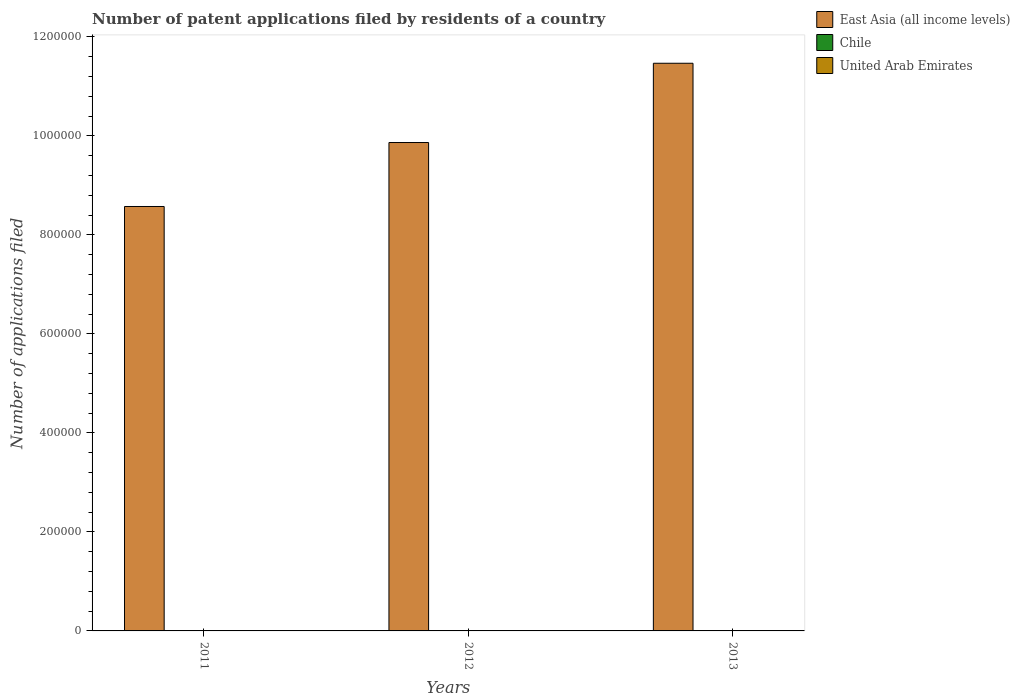How many groups of bars are there?
Give a very brief answer. 3. Are the number of bars on each tick of the X-axis equal?
Give a very brief answer. Yes. How many bars are there on the 2nd tick from the left?
Offer a terse response. 3. How many bars are there on the 1st tick from the right?
Make the answer very short. 3. In how many cases, is the number of bars for a given year not equal to the number of legend labels?
Offer a very short reply. 0. What is the number of applications filed in East Asia (all income levels) in 2012?
Provide a short and direct response. 9.87e+05. Across all years, what is the maximum number of applications filed in United Arab Emirates?
Ensure brevity in your answer.  26. Across all years, what is the minimum number of applications filed in Chile?
Your response must be concise. 336. In which year was the number of applications filed in East Asia (all income levels) minimum?
Offer a terse response. 2011. What is the total number of applications filed in East Asia (all income levels) in the graph?
Offer a terse response. 2.99e+06. What is the difference between the number of applications filed in East Asia (all income levels) in 2012 and that in 2013?
Keep it short and to the point. -1.60e+05. What is the difference between the number of applications filed in Chile in 2011 and the number of applications filed in East Asia (all income levels) in 2013?
Provide a succinct answer. -1.15e+06. What is the average number of applications filed in United Arab Emirates per year?
Ensure brevity in your answer.  21.33. In the year 2013, what is the difference between the number of applications filed in Chile and number of applications filed in East Asia (all income levels)?
Provide a short and direct response. -1.15e+06. What is the ratio of the number of applications filed in United Arab Emirates in 2012 to that in 2013?
Provide a short and direct response. 1.11. Is the number of applications filed in East Asia (all income levels) in 2012 less than that in 2013?
Give a very brief answer. Yes. What is the difference between the highest and the second highest number of applications filed in Chile?
Your response must be concise. 1. What is the difference between the highest and the lowest number of applications filed in United Arab Emirates?
Keep it short and to the point. 8. Is the sum of the number of applications filed in East Asia (all income levels) in 2012 and 2013 greater than the maximum number of applications filed in Chile across all years?
Make the answer very short. Yes. What does the 1st bar from the left in 2013 represents?
Your response must be concise. East Asia (all income levels). What does the 3rd bar from the right in 2011 represents?
Ensure brevity in your answer.  East Asia (all income levels). How many bars are there?
Your answer should be very brief. 9. Are all the bars in the graph horizontal?
Offer a very short reply. No. How many years are there in the graph?
Give a very brief answer. 3. Are the values on the major ticks of Y-axis written in scientific E-notation?
Your response must be concise. No. Does the graph contain any zero values?
Your response must be concise. No. Does the graph contain grids?
Your answer should be very brief. No. How many legend labels are there?
Your response must be concise. 3. What is the title of the graph?
Make the answer very short. Number of patent applications filed by residents of a country. Does "Montenegro" appear as one of the legend labels in the graph?
Offer a terse response. No. What is the label or title of the Y-axis?
Your answer should be compact. Number of applications filed. What is the Number of applications filed of East Asia (all income levels) in 2011?
Provide a short and direct response. 8.58e+05. What is the Number of applications filed of Chile in 2011?
Give a very brief answer. 339. What is the Number of applications filed in United Arab Emirates in 2011?
Offer a very short reply. 26. What is the Number of applications filed in East Asia (all income levels) in 2012?
Offer a terse response. 9.87e+05. What is the Number of applications filed of Chile in 2012?
Keep it short and to the point. 336. What is the Number of applications filed in United Arab Emirates in 2012?
Make the answer very short. 20. What is the Number of applications filed of East Asia (all income levels) in 2013?
Give a very brief answer. 1.15e+06. What is the Number of applications filed of Chile in 2013?
Make the answer very short. 340. What is the Number of applications filed of United Arab Emirates in 2013?
Provide a short and direct response. 18. Across all years, what is the maximum Number of applications filed in East Asia (all income levels)?
Give a very brief answer. 1.15e+06. Across all years, what is the maximum Number of applications filed of Chile?
Offer a terse response. 340. Across all years, what is the minimum Number of applications filed of East Asia (all income levels)?
Your answer should be compact. 8.58e+05. Across all years, what is the minimum Number of applications filed of Chile?
Make the answer very short. 336. Across all years, what is the minimum Number of applications filed of United Arab Emirates?
Provide a short and direct response. 18. What is the total Number of applications filed in East Asia (all income levels) in the graph?
Your answer should be very brief. 2.99e+06. What is the total Number of applications filed in Chile in the graph?
Provide a succinct answer. 1015. What is the total Number of applications filed of United Arab Emirates in the graph?
Keep it short and to the point. 64. What is the difference between the Number of applications filed of East Asia (all income levels) in 2011 and that in 2012?
Provide a succinct answer. -1.29e+05. What is the difference between the Number of applications filed in Chile in 2011 and that in 2012?
Offer a terse response. 3. What is the difference between the Number of applications filed of East Asia (all income levels) in 2011 and that in 2013?
Ensure brevity in your answer.  -2.89e+05. What is the difference between the Number of applications filed in East Asia (all income levels) in 2012 and that in 2013?
Offer a terse response. -1.60e+05. What is the difference between the Number of applications filed in Chile in 2012 and that in 2013?
Provide a succinct answer. -4. What is the difference between the Number of applications filed of United Arab Emirates in 2012 and that in 2013?
Your response must be concise. 2. What is the difference between the Number of applications filed of East Asia (all income levels) in 2011 and the Number of applications filed of Chile in 2012?
Ensure brevity in your answer.  8.57e+05. What is the difference between the Number of applications filed in East Asia (all income levels) in 2011 and the Number of applications filed in United Arab Emirates in 2012?
Your response must be concise. 8.58e+05. What is the difference between the Number of applications filed in Chile in 2011 and the Number of applications filed in United Arab Emirates in 2012?
Keep it short and to the point. 319. What is the difference between the Number of applications filed in East Asia (all income levels) in 2011 and the Number of applications filed in Chile in 2013?
Offer a very short reply. 8.57e+05. What is the difference between the Number of applications filed in East Asia (all income levels) in 2011 and the Number of applications filed in United Arab Emirates in 2013?
Keep it short and to the point. 8.58e+05. What is the difference between the Number of applications filed in Chile in 2011 and the Number of applications filed in United Arab Emirates in 2013?
Offer a very short reply. 321. What is the difference between the Number of applications filed in East Asia (all income levels) in 2012 and the Number of applications filed in Chile in 2013?
Offer a terse response. 9.86e+05. What is the difference between the Number of applications filed of East Asia (all income levels) in 2012 and the Number of applications filed of United Arab Emirates in 2013?
Provide a succinct answer. 9.87e+05. What is the difference between the Number of applications filed of Chile in 2012 and the Number of applications filed of United Arab Emirates in 2013?
Your answer should be very brief. 318. What is the average Number of applications filed in East Asia (all income levels) per year?
Your answer should be compact. 9.97e+05. What is the average Number of applications filed in Chile per year?
Your answer should be compact. 338.33. What is the average Number of applications filed of United Arab Emirates per year?
Provide a short and direct response. 21.33. In the year 2011, what is the difference between the Number of applications filed in East Asia (all income levels) and Number of applications filed in Chile?
Offer a terse response. 8.57e+05. In the year 2011, what is the difference between the Number of applications filed of East Asia (all income levels) and Number of applications filed of United Arab Emirates?
Give a very brief answer. 8.58e+05. In the year 2011, what is the difference between the Number of applications filed of Chile and Number of applications filed of United Arab Emirates?
Offer a terse response. 313. In the year 2012, what is the difference between the Number of applications filed in East Asia (all income levels) and Number of applications filed in Chile?
Offer a very short reply. 9.86e+05. In the year 2012, what is the difference between the Number of applications filed in East Asia (all income levels) and Number of applications filed in United Arab Emirates?
Your answer should be compact. 9.87e+05. In the year 2012, what is the difference between the Number of applications filed in Chile and Number of applications filed in United Arab Emirates?
Keep it short and to the point. 316. In the year 2013, what is the difference between the Number of applications filed in East Asia (all income levels) and Number of applications filed in Chile?
Offer a very short reply. 1.15e+06. In the year 2013, what is the difference between the Number of applications filed of East Asia (all income levels) and Number of applications filed of United Arab Emirates?
Your answer should be compact. 1.15e+06. In the year 2013, what is the difference between the Number of applications filed in Chile and Number of applications filed in United Arab Emirates?
Offer a terse response. 322. What is the ratio of the Number of applications filed of East Asia (all income levels) in 2011 to that in 2012?
Ensure brevity in your answer.  0.87. What is the ratio of the Number of applications filed in Chile in 2011 to that in 2012?
Keep it short and to the point. 1.01. What is the ratio of the Number of applications filed of United Arab Emirates in 2011 to that in 2012?
Provide a short and direct response. 1.3. What is the ratio of the Number of applications filed of East Asia (all income levels) in 2011 to that in 2013?
Your response must be concise. 0.75. What is the ratio of the Number of applications filed in United Arab Emirates in 2011 to that in 2013?
Give a very brief answer. 1.44. What is the ratio of the Number of applications filed of East Asia (all income levels) in 2012 to that in 2013?
Offer a very short reply. 0.86. What is the ratio of the Number of applications filed in Chile in 2012 to that in 2013?
Offer a very short reply. 0.99. What is the ratio of the Number of applications filed of United Arab Emirates in 2012 to that in 2013?
Provide a succinct answer. 1.11. What is the difference between the highest and the second highest Number of applications filed in East Asia (all income levels)?
Give a very brief answer. 1.60e+05. What is the difference between the highest and the second highest Number of applications filed in United Arab Emirates?
Keep it short and to the point. 6. What is the difference between the highest and the lowest Number of applications filed of East Asia (all income levels)?
Offer a very short reply. 2.89e+05. What is the difference between the highest and the lowest Number of applications filed in United Arab Emirates?
Provide a short and direct response. 8. 